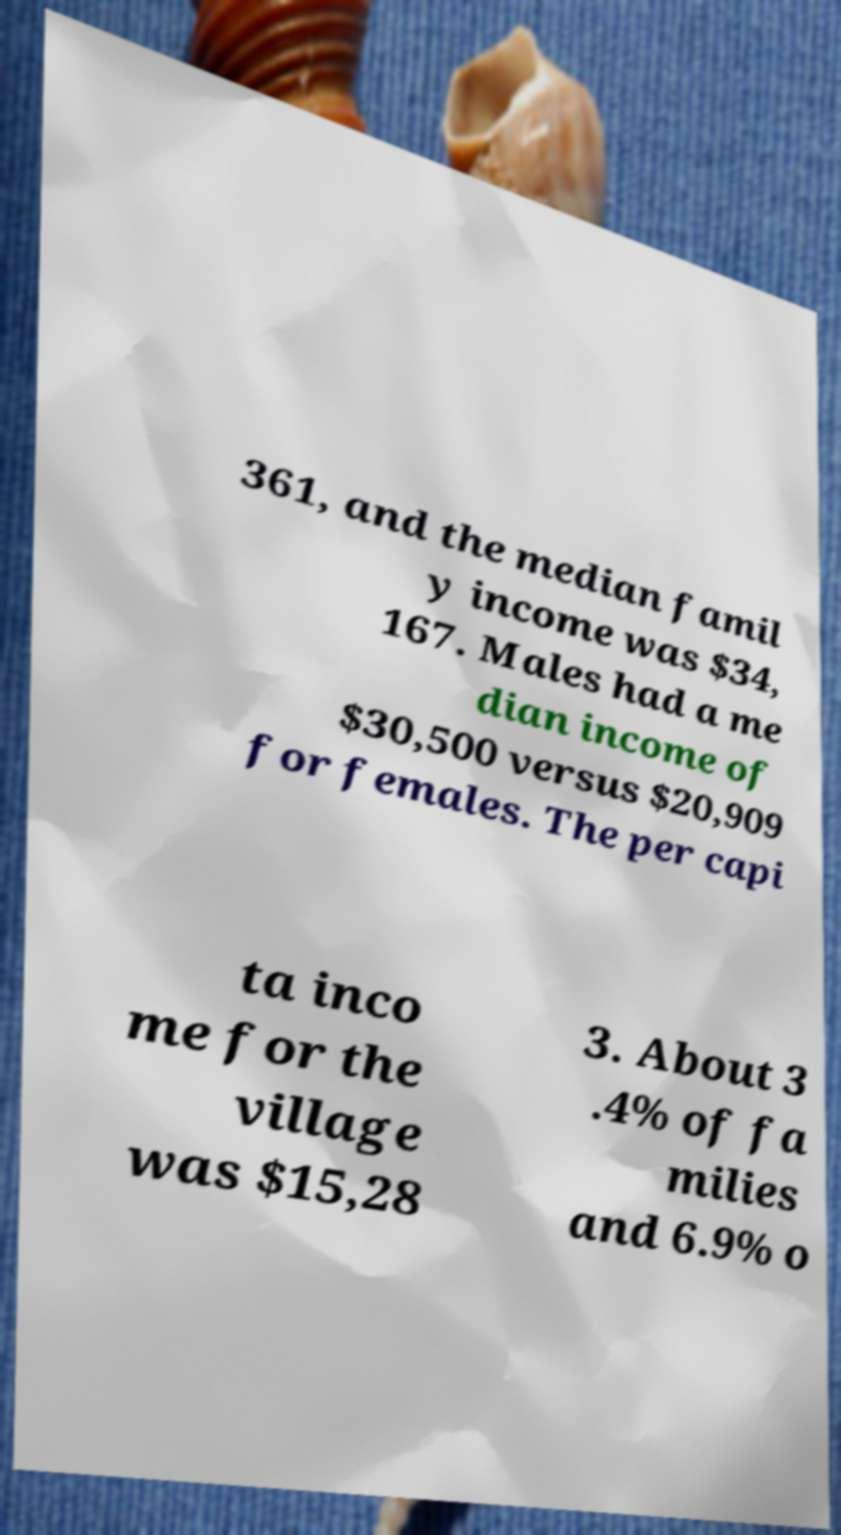Could you extract and type out the text from this image? 361, and the median famil y income was $34, 167. Males had a me dian income of $30,500 versus $20,909 for females. The per capi ta inco me for the village was $15,28 3. About 3 .4% of fa milies and 6.9% o 